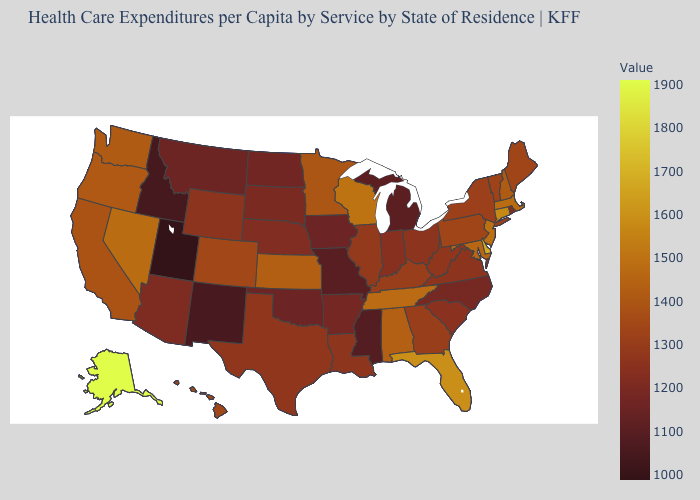Which states have the highest value in the USA?
Keep it brief. Alaska. 